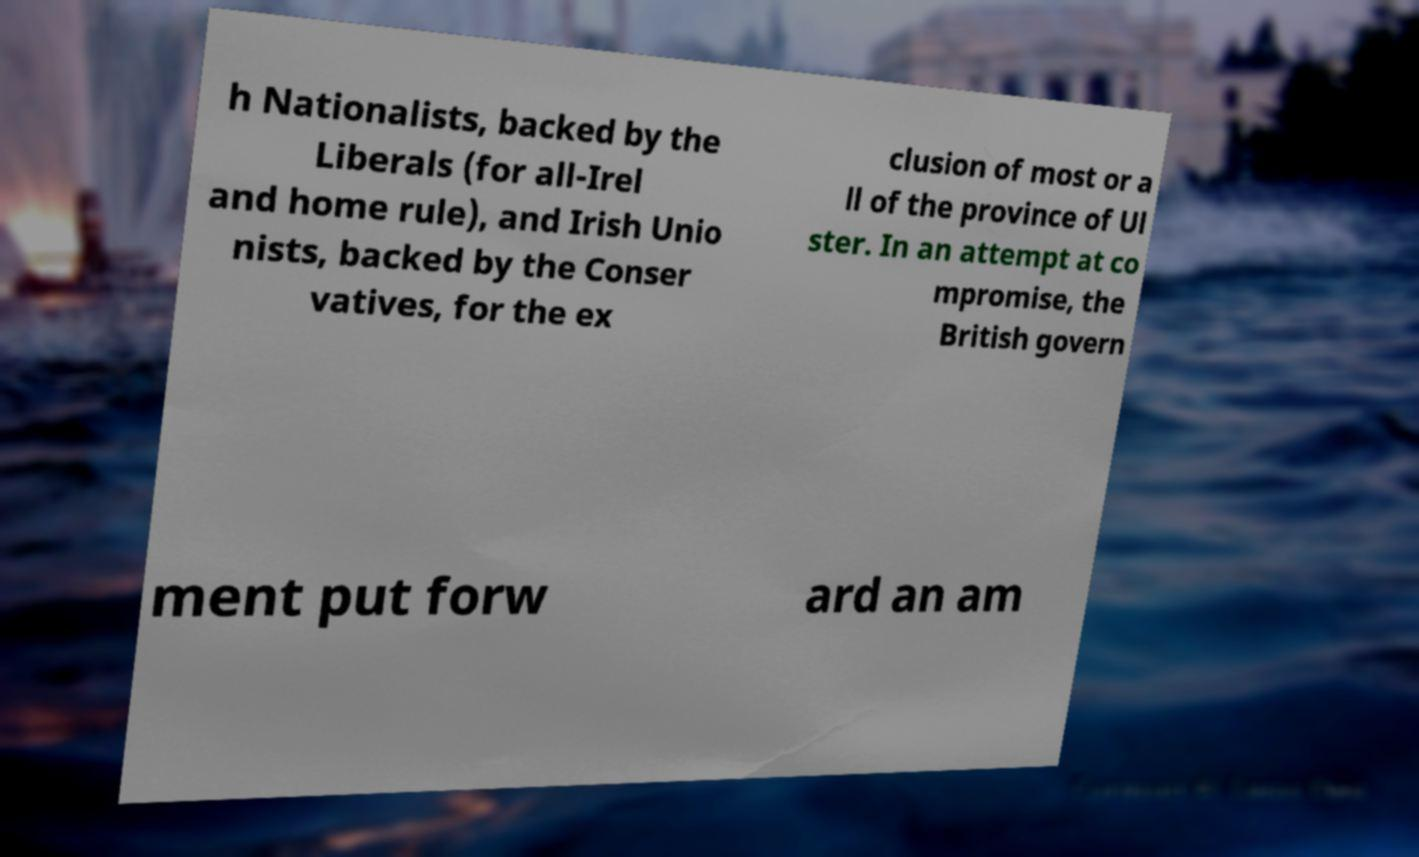I need the written content from this picture converted into text. Can you do that? h Nationalists, backed by the Liberals (for all-Irel and home rule), and Irish Unio nists, backed by the Conser vatives, for the ex clusion of most or a ll of the province of Ul ster. In an attempt at co mpromise, the British govern ment put forw ard an am 